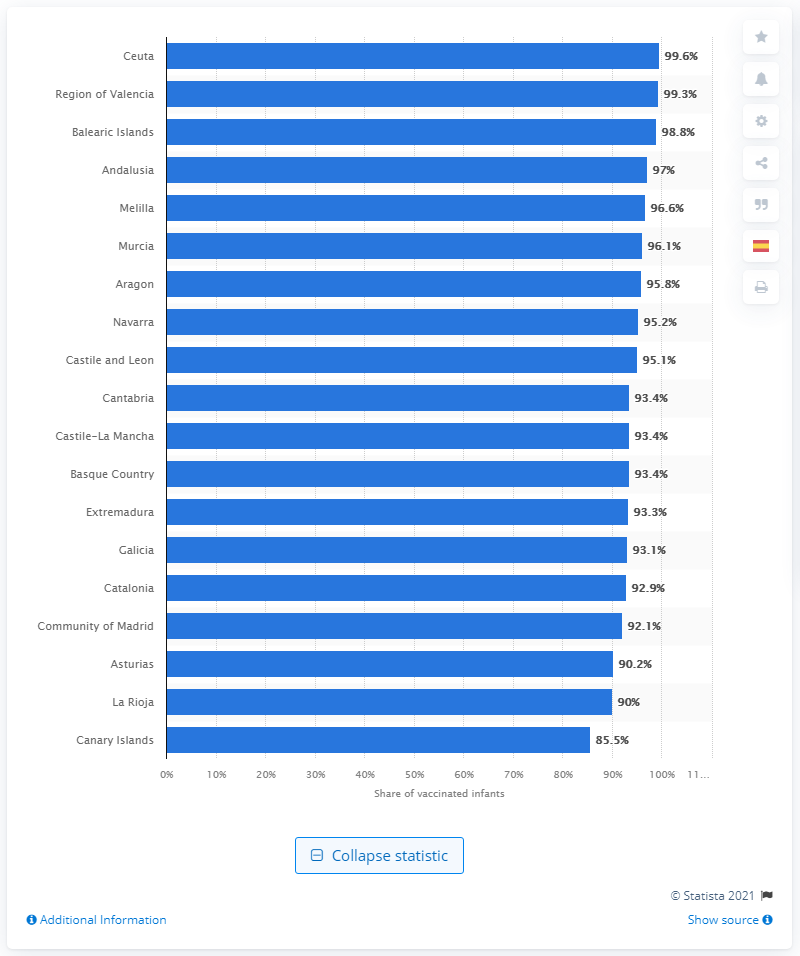Draw attention to some important aspects in this diagram. According to data, 99.6% of infants in Ceuta were vaccinated against MMR. 